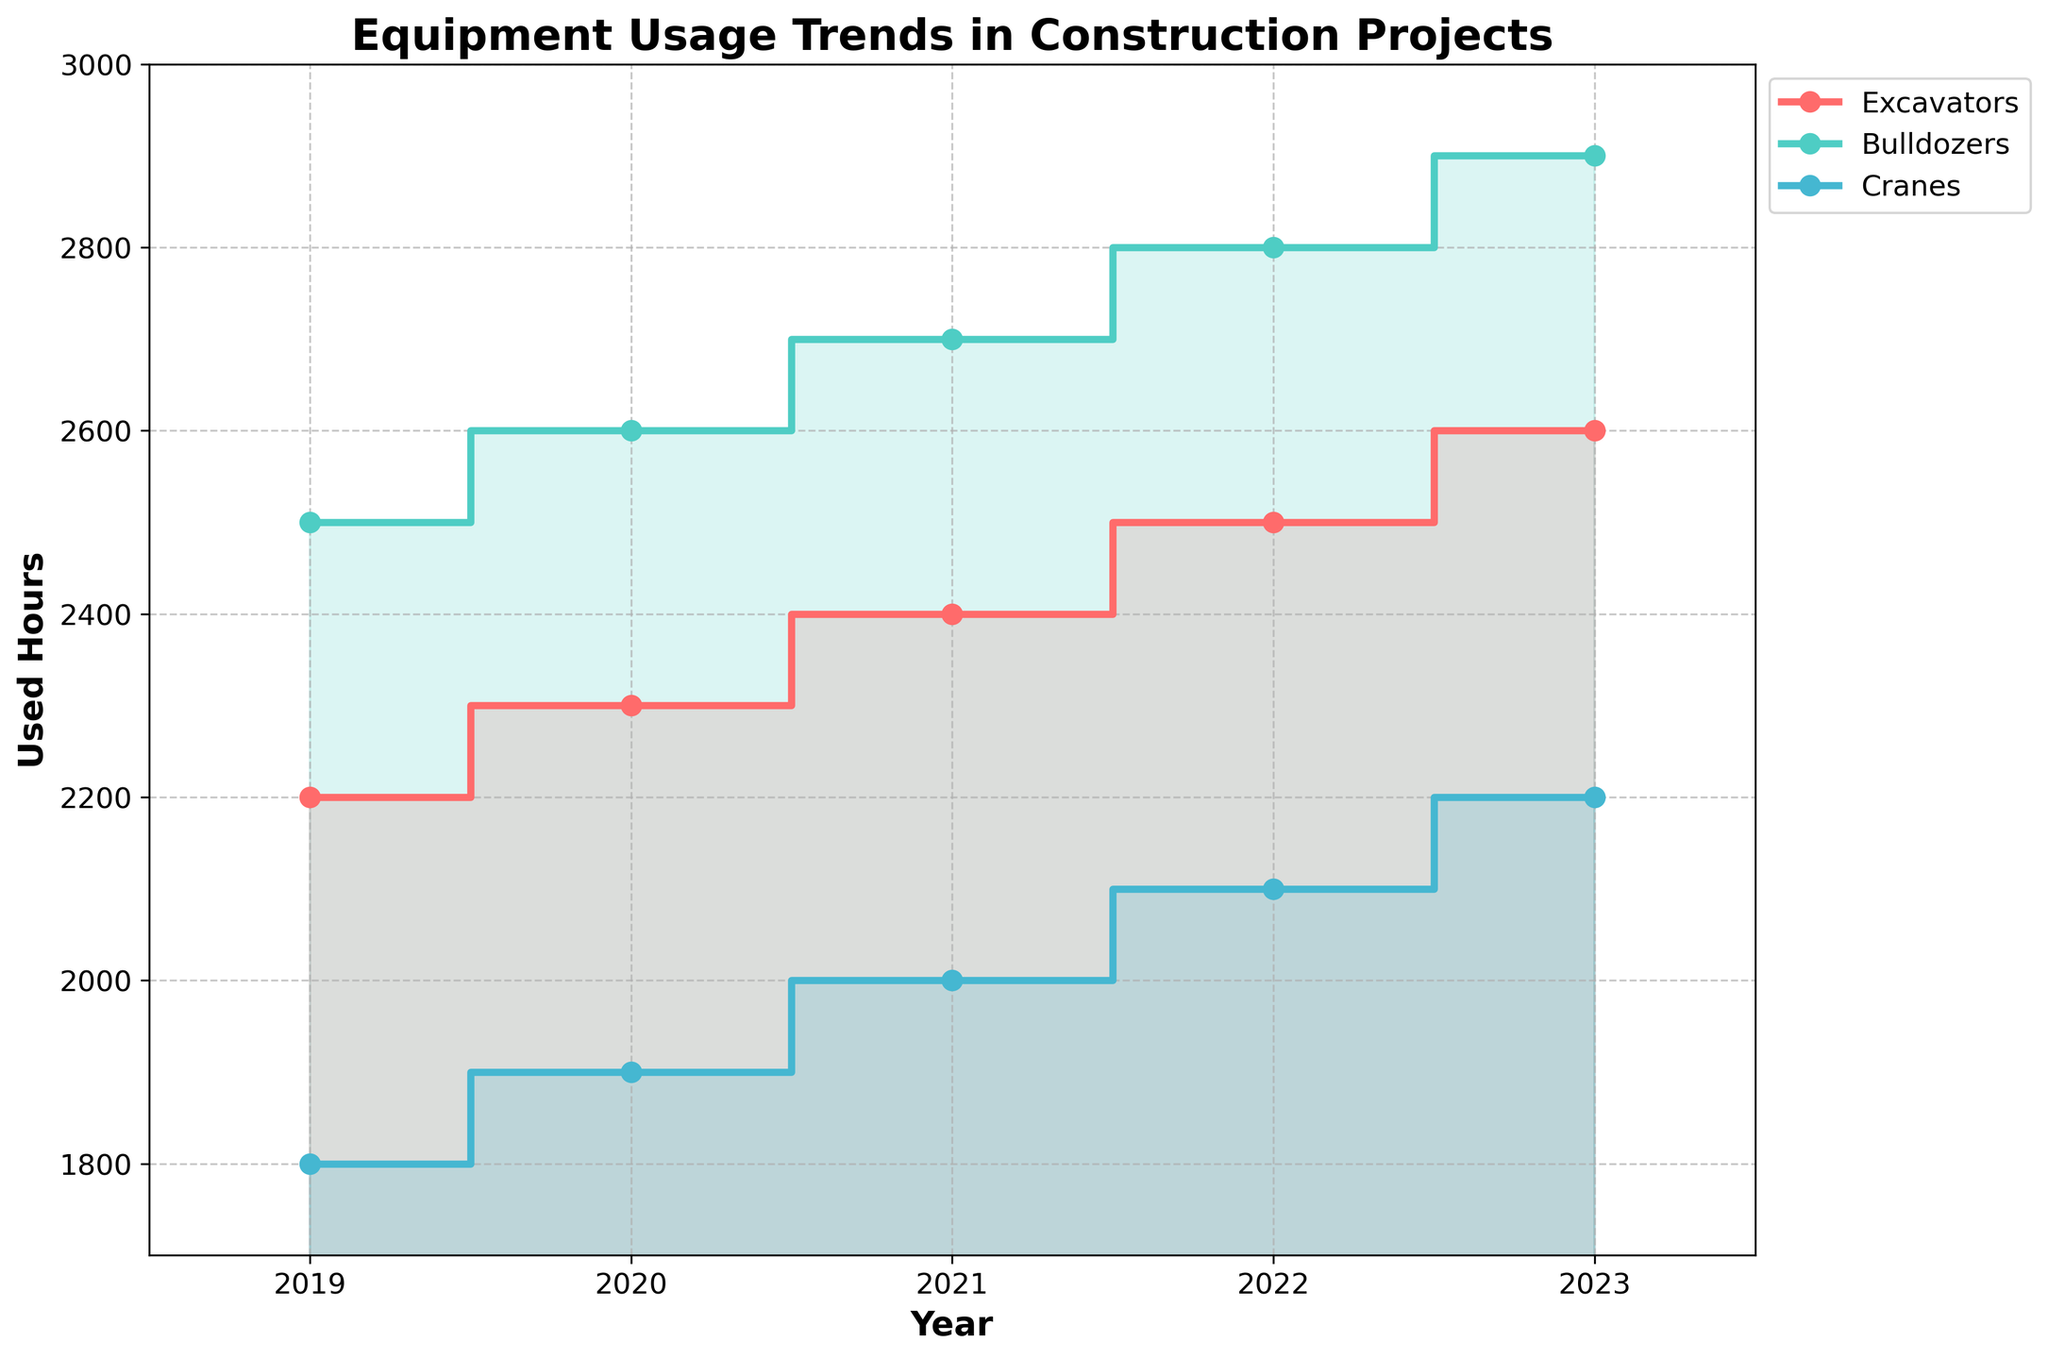What is the title of the plot? The title is usually shown at the top of the plot. This plot's title is visible there.
Answer: Equipment Usage Trends in Construction Projects Which years are covered in the plot? The x-axis of the plot lists the years included in the data. Simply reading these values will give us the answer.
Answer: 2019 to 2023 What is the range of the y-axis? By examining the y-axis labels and the limits set on the axis, we can determine the range. The minimum visible value is 1700, and the maximum visible value is 3000.
Answer: 1700 to 3000 How has the usage of Excavators changed over the years? By following the line representing Excavators (colored in one of the specific colors) from left to right along the x-axis, we can observe the trend.
Answer: Increased Which equipment type had the highest usage in 2023? By looking at the end of the plot for the year 2023 and finding the highest point, we can determine which line is at the top.
Answer: Bulldozers What is the difference in used hours for Bulldozers between 2019 and 2023? Locate the used hours for Bulldozers in 2019 and 2023 on the y-axis, and subtract the 2019 value from the 2023 value. Bullodzers' used hours in 2019 were 2500, and in 2023 they were 2900. So, 2900 - 2500 = 400.
Answer: 400 Which equipment showed the smallest increase in used hours from 2019 to 2023? By comparing the end points of each type of equipment from 2019 to 2023, we can see the differences. Cranes have the smallest increase.
Answer: Cranes Which year had the highest overall usage for all equipment types? Sum up the used hours for all equipment types for each year and compare these sums. The highest sum will indicate the year with the highest overall usage.
Answer: 2023 How do the trends of Crane usage compare to those of Excavators? By examining the lines representing Cranes and Excavators across the years, we can compare their trends. We look for similarities or differences in the steps and slopes of the lines. Both show an increasing trend but at different rates.
Answer: Both increased, Cranes had a smaller increase What is the average used hours for Bulldozers from 2019 to 2023? To find the average, add the used hours for Bulldozers from each year, then divide by the number of years. (2500 + 2600 + 2700 + 2800 + 2900) / 5 = 13500 / 5 = 2700
Answer: 2700 